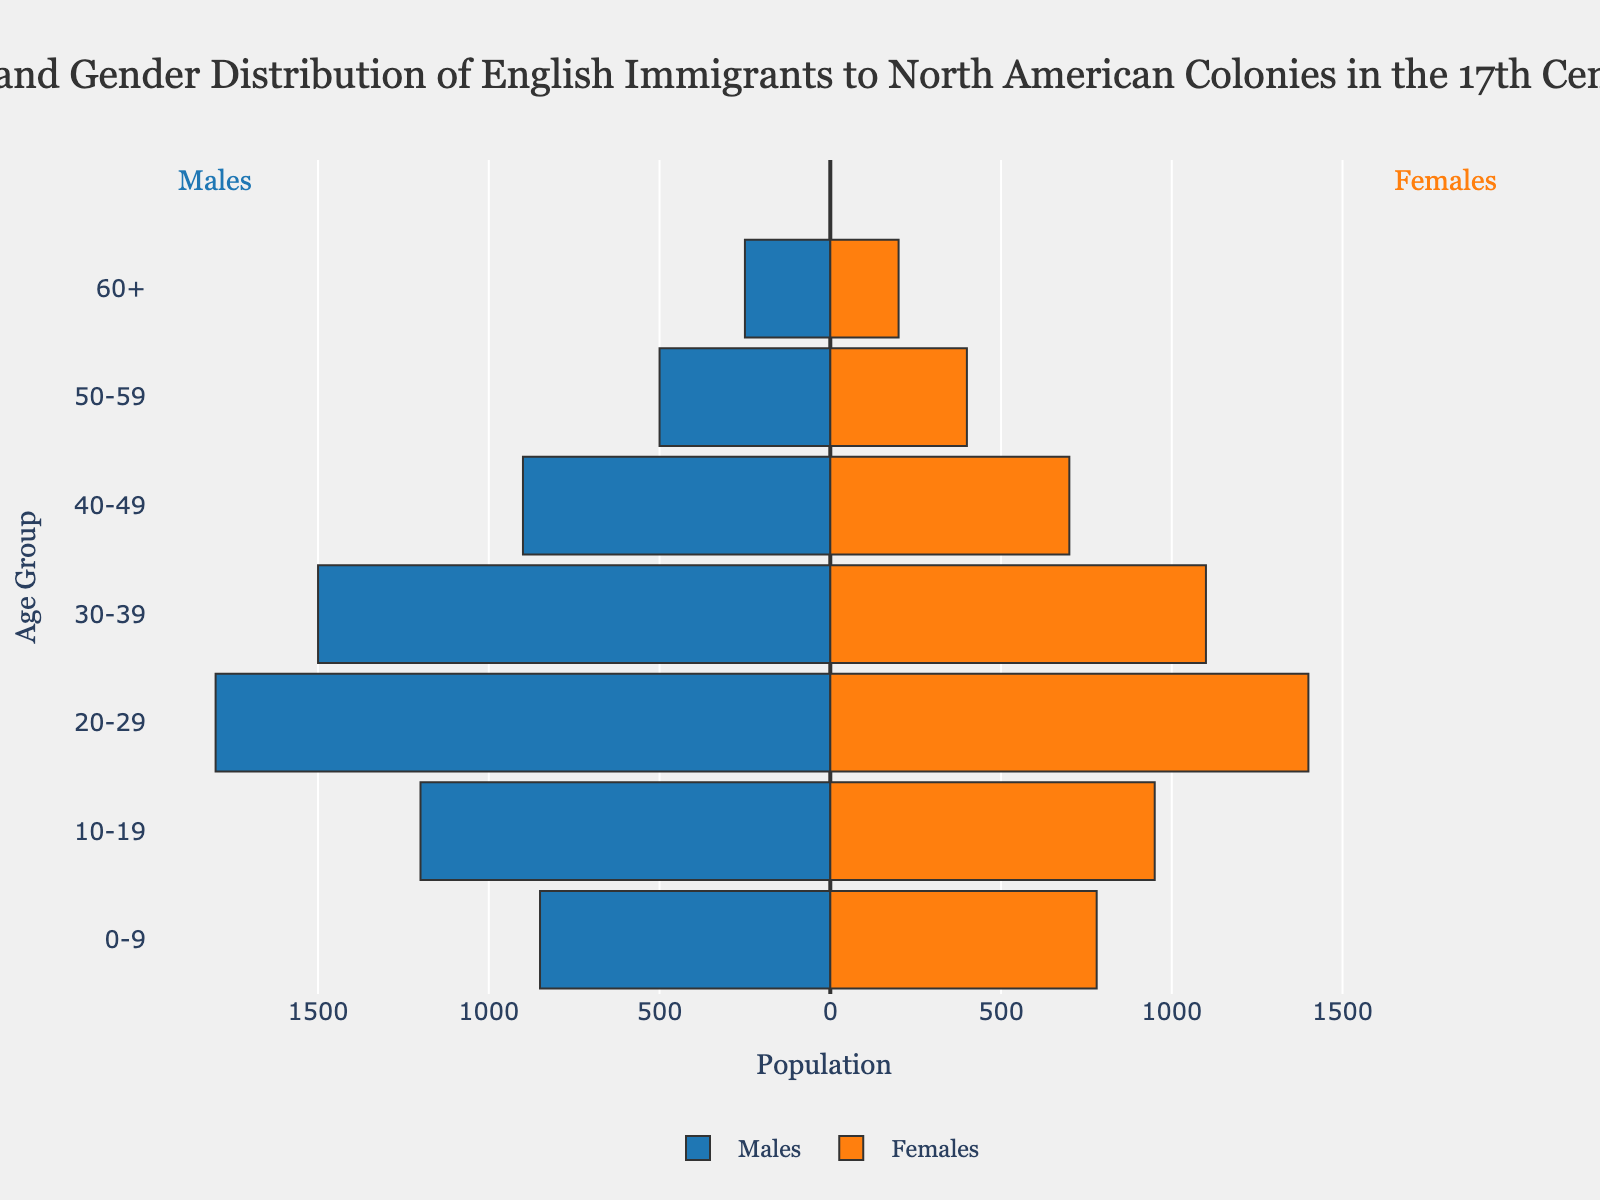What is the age range with the highest number of male immigrants? The age range with the highest number of male immigrants is indicated by the longest bar on the left side of the pyramid, which corresponds to males. The longest bar appears in the "20-29" age group.
Answer: 20-29 Which age group has the closest number of male and female immigrants? To find the age group with the closest number of male and female immigrants, compare the lengths of the bars for males and females within each age group and look for the smallest difference. The "0-9" age group has 850 males and 780 females, a difference of 70, which is the smallest.
Answer: 0-9 How many more male immigrants are there in the 20-29 age group compared to the 30-39 age group? Subtract the number of males in the 30-39 age group (1500) from the number of males in the 20-29 age group (1800). \(1800 - 1500 = 300\).
Answer: 300 Which gender has a higher population in the 40-49 age group? Compare the bars for males and females in the 40-49 age group. The bar for males is longer with 900 males compared to 700 females.
Answer: Males What is the total number of female immigrants in the 10-19, 20-29, and 30-39 age groups? Sum the number of females in the 10-19 (950), 20-29 (1400), and 30-39 (1100) age groups. \(950 + 1400 + 1100 = 3450\).
Answer: 3450 In which age group is there the smallest total population of immigrants? Add the male and female populations for each age group and find the smallest sum. The "60+" age group has 250 males and 200 females, totaling \(250 + 200 = 450\), which is the smallest.
Answer: 60+ By how much does the male population exceed the female population in the 50-59 age group? Subtract the number of females (400) from the number of males (500) in the 50-59 age group. \(500 - 400 = 100\).
Answer: 100 What is the age range with the highest number of female immigrants? The age range with the highest number of female immigrants is indicated by the longest bar on the right side of the pyramid, which corresponds to females. The longest bar appears in the "20-29" age group.
Answer: 20-29 Which age group has the largest population difference between males and females? Calculate the difference between males and females for each age group and find the largest value. The "20-29" age group has 1800 males and 1400 females, a difference of 400, which is the largest.
Answer: 20-29 